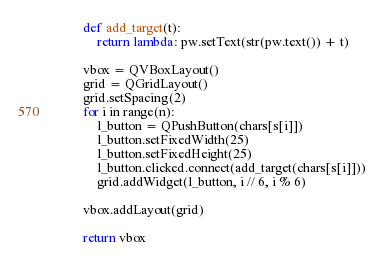Convert code to text. <code><loc_0><loc_0><loc_500><loc_500><_Python_>        def add_target(t):
            return lambda: pw.setText(str(pw.text()) + t)

        vbox = QVBoxLayout()
        grid = QGridLayout()
        grid.setSpacing(2)
        for i in range(n):
            l_button = QPushButton(chars[s[i]])
            l_button.setFixedWidth(25)
            l_button.setFixedHeight(25)
            l_button.clicked.connect(add_target(chars[s[i]]))
            grid.addWidget(l_button, i // 6, i % 6)

        vbox.addLayout(grid)

        return vbox
</code> 